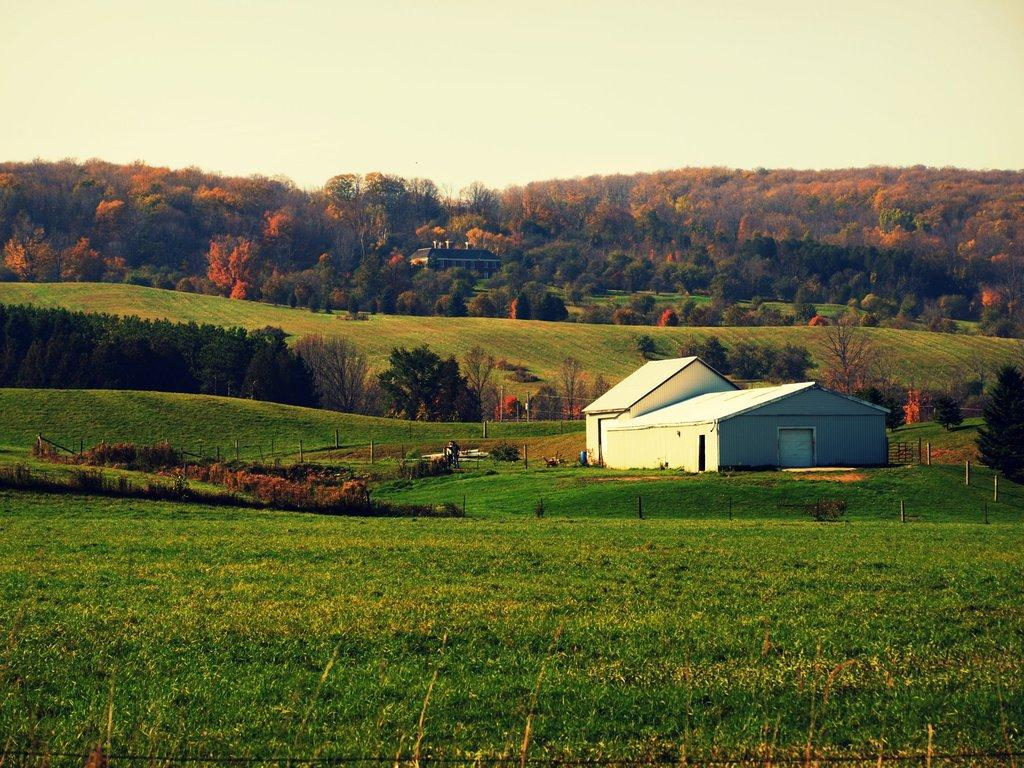What type of natural elements can be seen in the image? There are trees and plants in the image. What structure is located in the middle of the image? There is a shelter house in the middle of the image. What is visible at the top of the image? The sky is visible at the top of the image. Can you see the partner of the owl sitting on the tree in the image? There is no owl or its partner present in the image. Is there any jelly visible on the shelter house in the image? There is no jelly present on the shelter house or anywhere else in the image. 